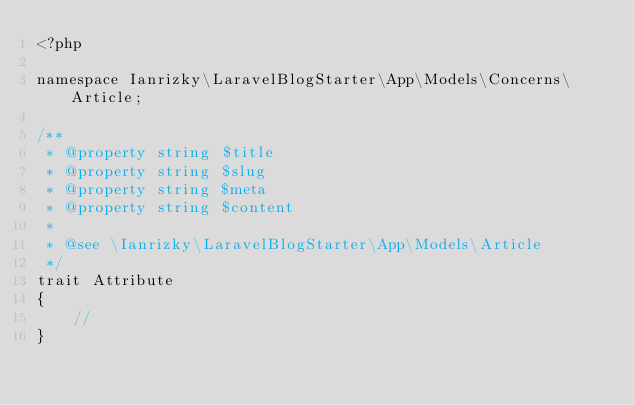Convert code to text. <code><loc_0><loc_0><loc_500><loc_500><_PHP_><?php

namespace Ianrizky\LaravelBlogStarter\App\Models\Concerns\Article;

/**
 * @property string $title
 * @property string $slug
 * @property string $meta
 * @property string $content
 *
 * @see \Ianrizky\LaravelBlogStarter\App\Models\Article
 */
trait Attribute
{
    //
}
</code> 